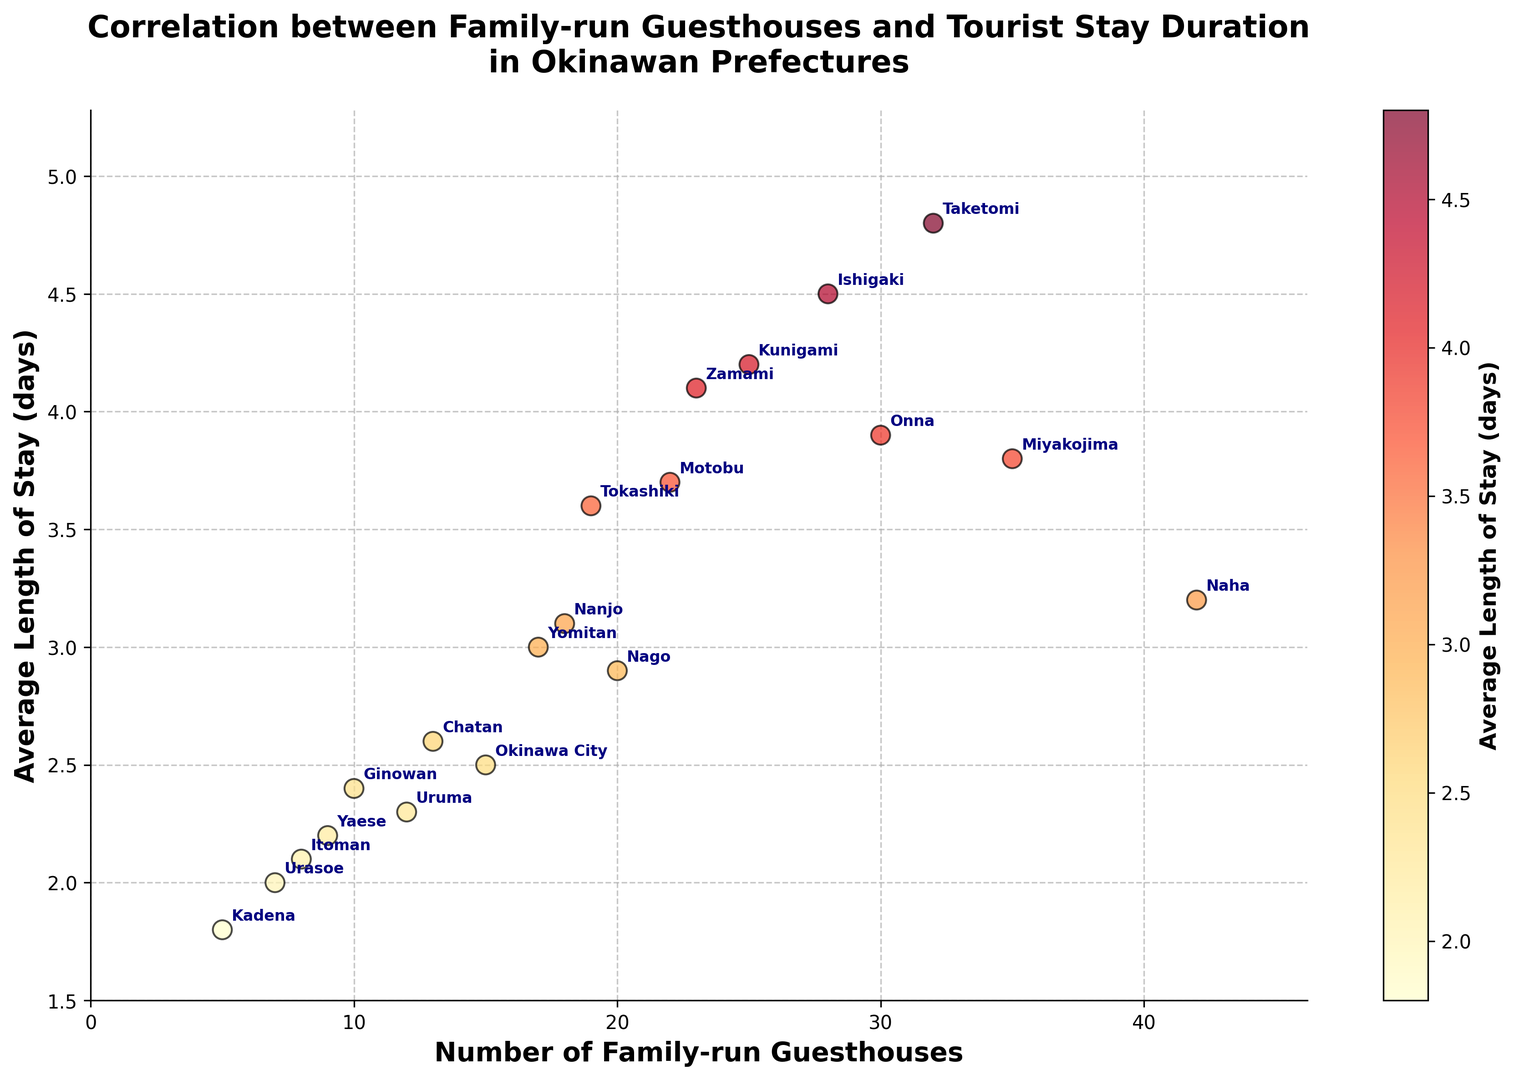In which prefecture is the average length of tourist stays the longest? By looking at the y-axis (Average Length of Stay) and identifying the highest point, which corresponds to the prefecture. According to the plot, the highest y-value is 4.8 days associated with Taketomi.
Answer: Taketomi How many guesthouses are there in Miyakojima, and how does it compare to the number of guesthouses in Zamami? Reference the x-axis (Number of Family-run Guesthouses) for both Miyakojima and Zamami. Miyakojima has 35 guesthouses, while Zamami has 23 guesthouses. Comparing the two values, Miyakojima has more guesthouses than Zamami.
Answer: Miyakojima: 35, more than Zamami What is the difference in the average length of stay between Urasoe and Naha? Identify the y-values for Urasoe and Naha from the plot. Urasoe has an average length of stay of 2.0 days, and Naha has 3.2 days. Subtract 2.0 from 3.2 to find the difference.
Answer: 1.2 days Which prefectures have an average stay duration shorter than 3 days? Look at the y-axis values and identify data points below 3 days. Prefectures such as Urasoe, Yaese, Kadena, Itoman, Ginowan, Uruma, Okinawa City, and Nago fall in this category.
Answer: Urasoe, Yaese, Kadena, Itoman, Ginowan, Uruma, Okinawa City, Nago Which prefecture has the smallest number of family-run guesthouses, and what is their average length of stay? Identify the smallest x-value for Number of Family-run Guesthouses, which corresponds to the prefecture. Urasoe has the smallest number with 7 guesthouses and the average length of stay in Urasoe is 2.0 days.
Answer: Urasoe, 2.0 days Is there a positive correlation between the number of family-run guesthouses and the average length of tourist stays? Observe the overall trend of the data points. Generally, as the number of family-run guesthouses increases, the average length of stays also increases, indicating a positive correlation.
Answer: Yes Among Ishigaki, Miyakojima, and Onna, which prefecture has the highest average length of stay? Compare the y-values corresponding to Ishigaki, Miyakojima, and Onna. Ishigaki has 4.5 days, Miyakojima has 3.8 days, and Onna has 3.9 days. So, Ishigaki has the highest average length of stay.
Answer: Ishigaki Do Nanjo and Yomitan have an average length of stay greater than or equal to 3 days? Identify the y-values for Nanjo and Yomitan. Nanjo is at 3.1 days, and Yomitan is at 3.0 days. Both values are greater than or equal to 3 days.
Answer: Yes What is the combined number of family-run guesthouses in Nago and Tokashiki? Locate the x-values for Nago (20) and Tokashiki (19). Sum these values to find the total number of guesthouses. 20 + 19 = 39
Answer: 39 guesthouses List two prefectures with an average length of stay above 4 days that have fewer than 30 family-run guesthouses. Identify data points above 4 on the y-axis and check if the corresponding x-values are less than 30. Prefectures meeting these criteria are Kunigami (4.2 days, 25 guesthouses) and Zamami (4.1 days, 23 guesthouses).
Answer: Kunigami, Zamami 